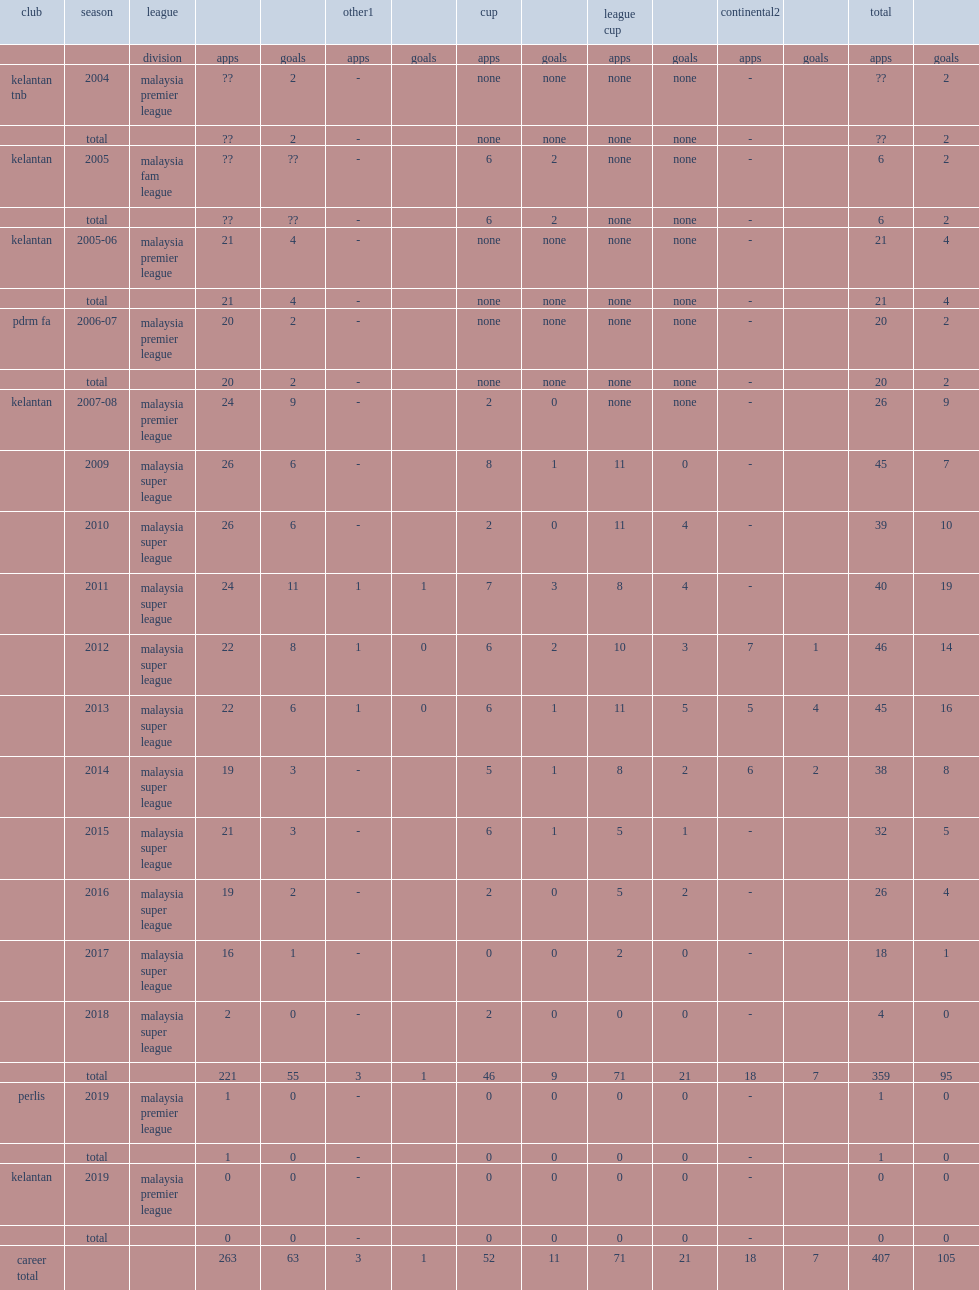In 2006-07 season, which league did badhri move to? Malaysia premier league. 